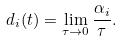<formula> <loc_0><loc_0><loc_500><loc_500>d _ { i } ( t ) = \lim _ { \tau \to 0 } \frac { \alpha _ { i } } { \tau } .</formula> 